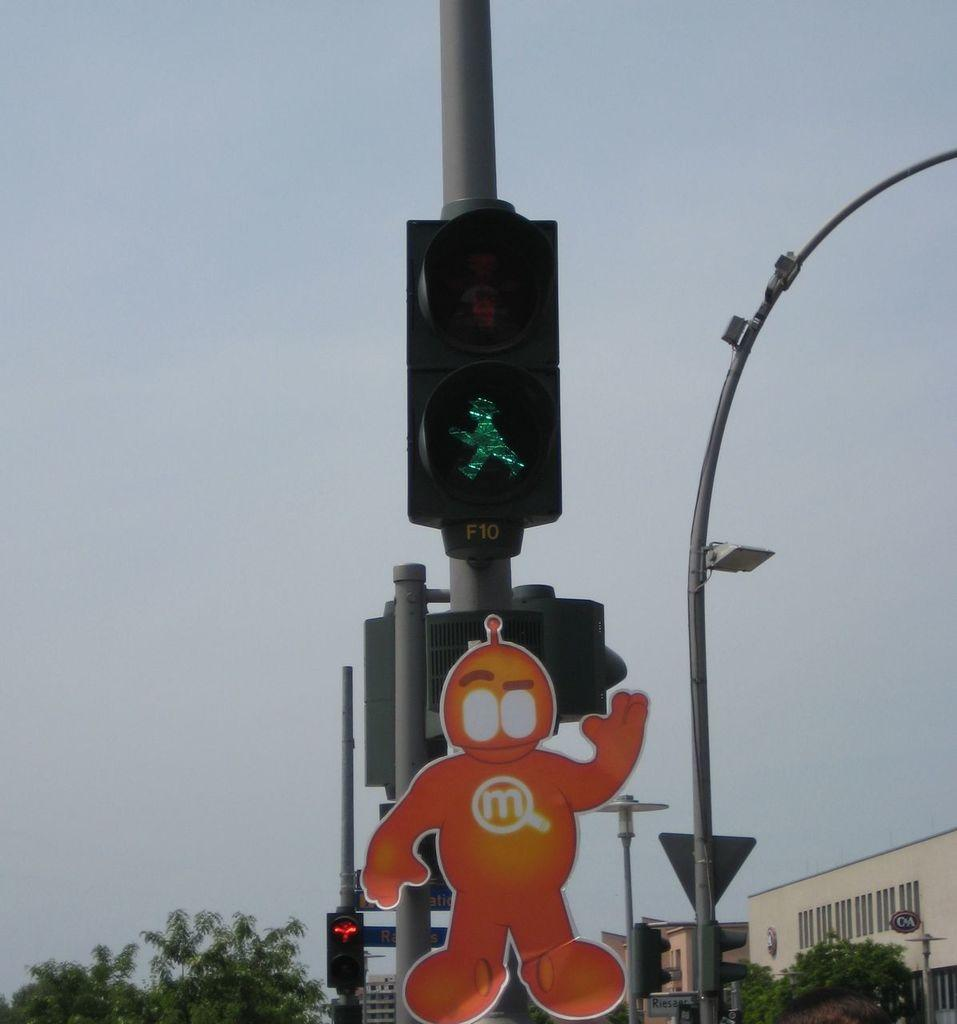What type of structures can be seen in the image? There are buildings in the image. What can be found at intersections in the image? There are traffic lights in the image. What is attached to a pole in the image? There is a sticker attached to a pole in the image. What type of vegetation is present in the image? There are trees in the image. What is a tall, vertical structure in the image? There is a light pole in the image. What is visible in the background of the image? The sky is visible in the image. Where is the hen sitting in the image? There is no hen present in the image. What type of haircut is the table getting in the image? There is no table or haircut present in the image. 